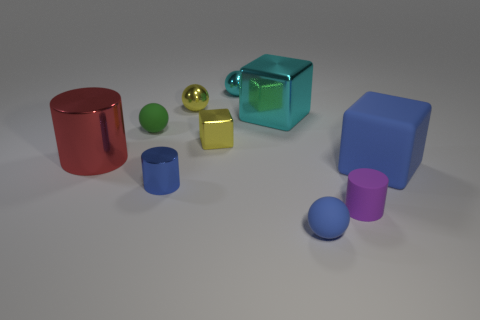Subtract all cylinders. How many objects are left? 7 Add 3 tiny green objects. How many tiny green objects exist? 4 Subtract 0 brown cylinders. How many objects are left? 10 Subtract all big cylinders. Subtract all blue matte spheres. How many objects are left? 8 Add 4 purple cylinders. How many purple cylinders are left? 5 